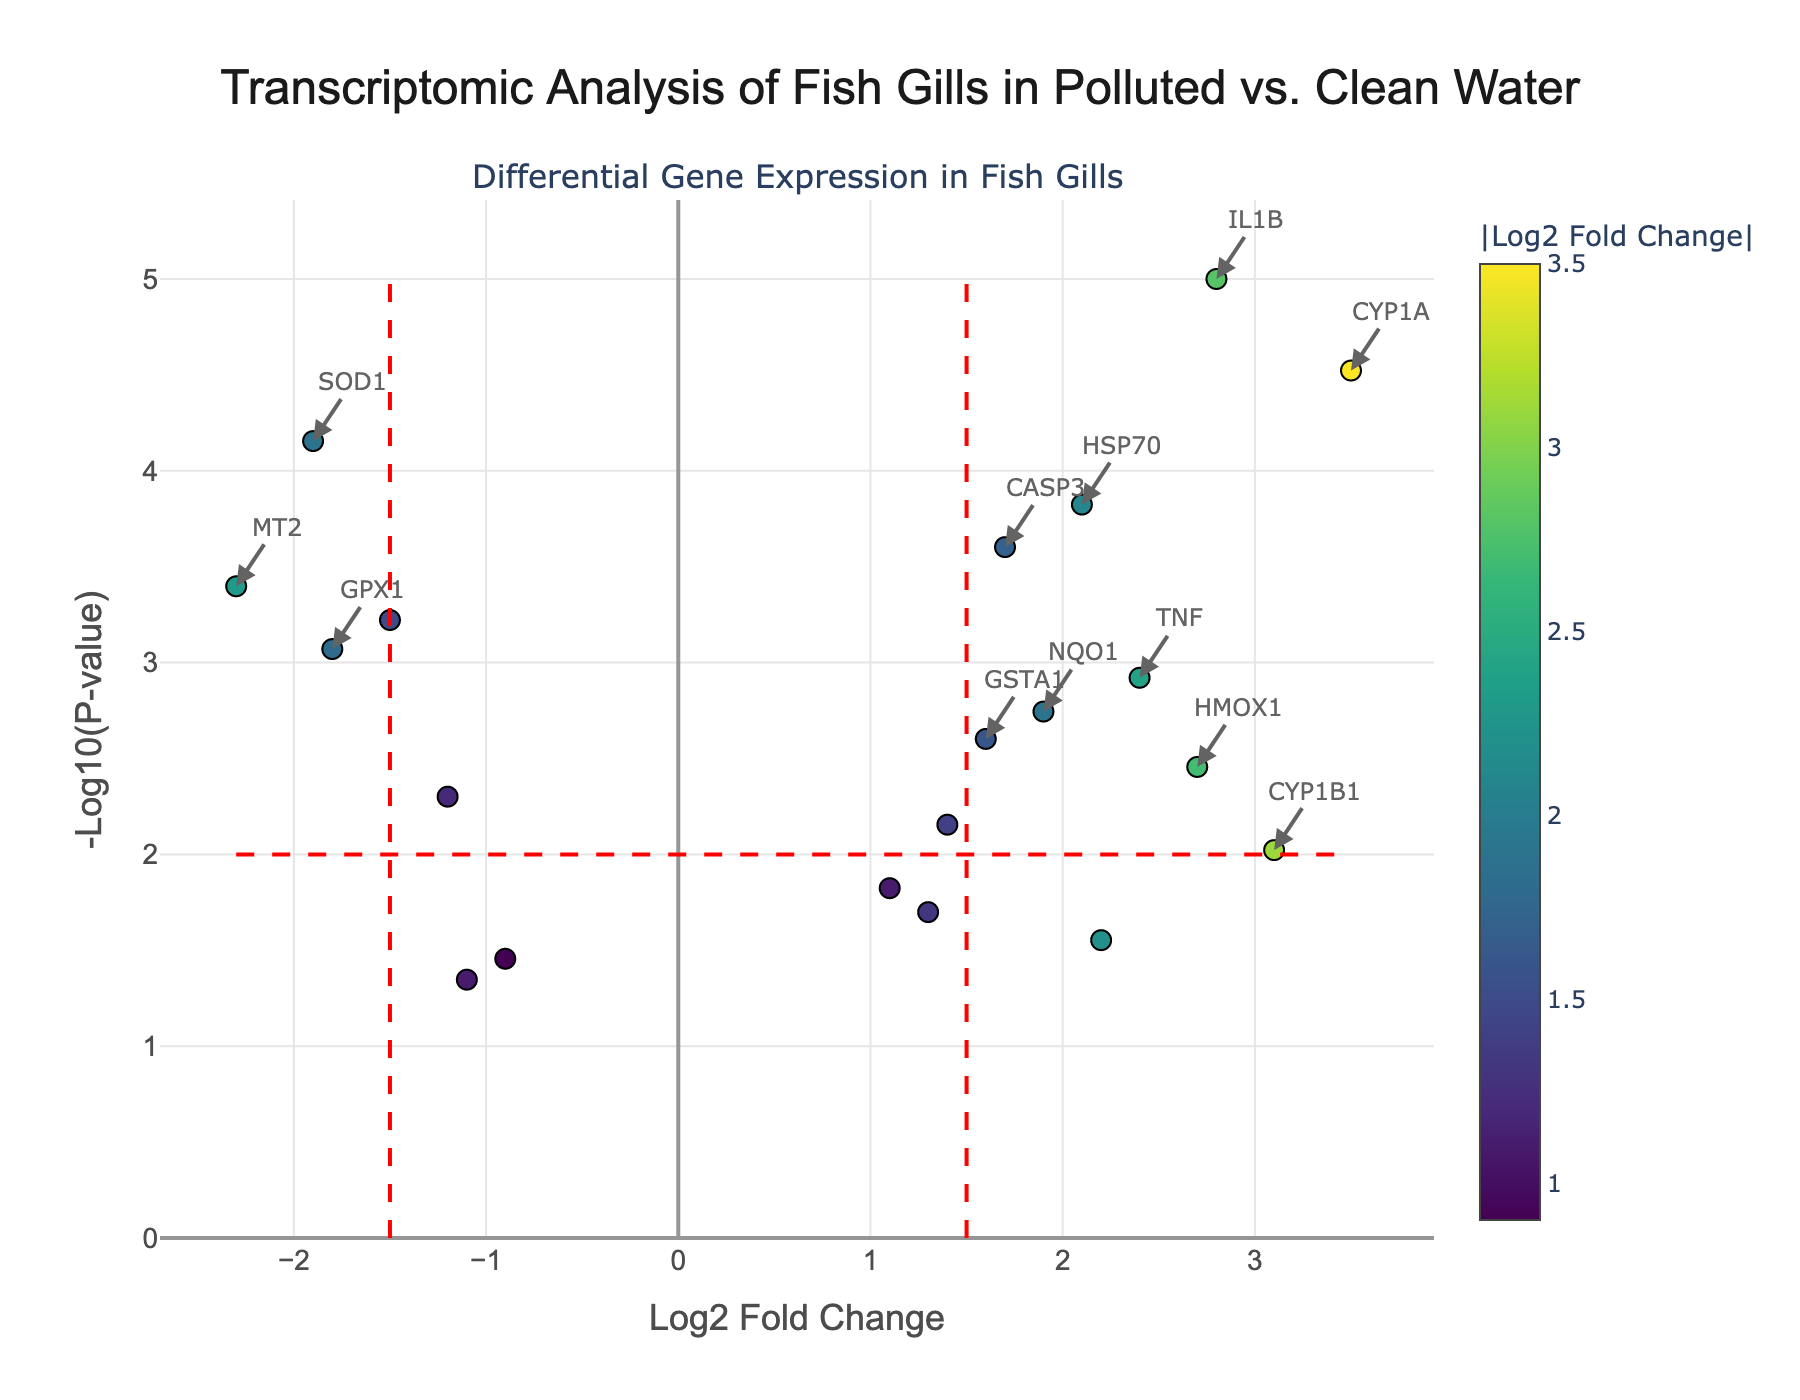what is the title of the figure? The title of the figure is presented at the top in larger font size. In this case, it reads "Transcriptomic Analysis of Fish Gills in Polluted vs. Clean Water".
Answer: Transcriptomic Analysis of Fish Gills in Polluted vs. Clean Water what does the y-axis represent? The y-axis is labeled with "-Log10(P-value)" which indicates the negative logarithm (base 10) of the P-value.
Answer: -Log10(P-value) what does the x-axis represent? The x-axis is labeled with "Log2 Fold Change" which indicates the logarithm base 2 of the fold change in gene expression levels.
Answer: Log2 Fold Change how many genes have a log2 fold change greater than 2.5? By examining the plot, there are 4 genes with a log2 fold change greater than 2.5 (IL1B, CYP1A, HMOX1, CYP1B1).
Answer: 4 which gene has the lowest p-value? The gene with the lowest p-value is the one with the highest -Log10(p-value). In this case, it is IL1B which has the highest point on the y-axis.
Answer: IL1B how many genes have significant fold changes and p-values? Significant genes have a log2 fold change > 1.5 or < -1.5 and a p-value < 0.01. By examining the annotations and threshold lines, there are 6 genes that fulfill these criteria (IL1B, CYP1A, HSP70, CASP3, SOD1, MT2).
Answer: 6 what is the log2 fold change of the gene AHR? Hovering over the points or reading the data directly indicates that AHR has a log2 fold change of 2.2.
Answer: 2.2 how does the expression of SOD1 compare to IL1B? SOD1 has a log2 fold change of -1.9 (downregulated) and IL1B has a log2 fold change of 2.8 (upregulated). IL1B is upregulated more significantly compared to SOD1 which is downregulated.
Answer: IL1B is more upregulated than SOD1 is downregulated what genes are both upregulated and have p-values less than 0.001? The genes that meet these criteria are IL1B, CYP1A, HSP70, CASP3, and TNF based on their positions in the plot and annotations.
Answer: IL1B, CYP1A, HSP70, CASP3, TNF 